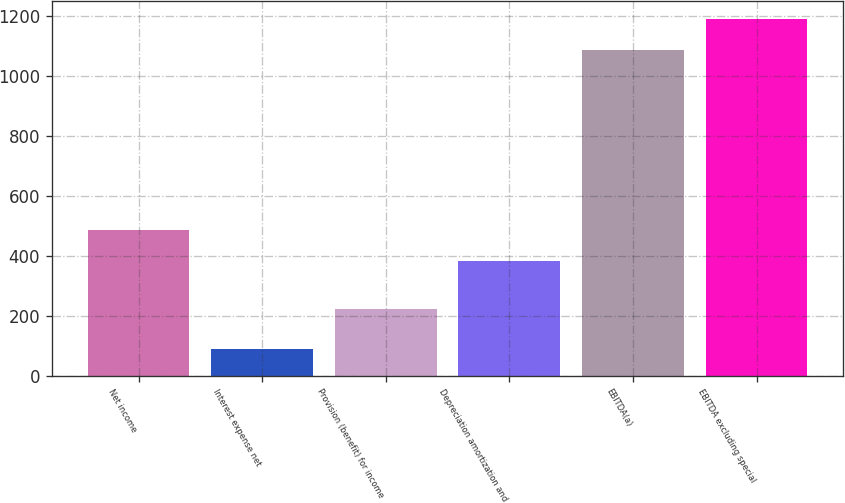Convert chart to OTSL. <chart><loc_0><loc_0><loc_500><loc_500><bar_chart><fcel>Net income<fcel>Interest expense net<fcel>Provision (benefit) for income<fcel>Depreciation amortization and<fcel>EBITDA(a)<fcel>EBITDA excluding special<nl><fcel>486.52<fcel>88.4<fcel>221.7<fcel>381<fcel>1083.7<fcel>1189.22<nl></chart> 